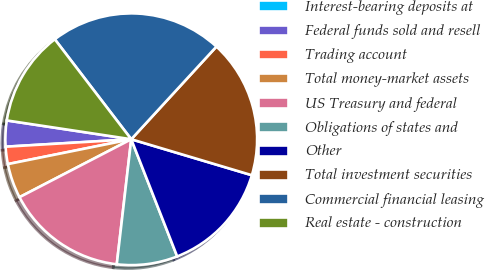Convert chart. <chart><loc_0><loc_0><loc_500><loc_500><pie_chart><fcel>Interest-bearing deposits at<fcel>Federal funds sold and resell<fcel>Trading account<fcel>Total money-market assets<fcel>US Treasury and federal<fcel>Obligations of states and<fcel>Other<fcel>Total investment securities<fcel>Commercial financial leasing<fcel>Real estate - construction<nl><fcel>0.0%<fcel>3.33%<fcel>2.22%<fcel>4.45%<fcel>15.55%<fcel>7.78%<fcel>14.44%<fcel>17.78%<fcel>22.22%<fcel>12.22%<nl></chart> 